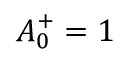<formula> <loc_0><loc_0><loc_500><loc_500>A _ { 0 } ^ { + } = 1</formula> 